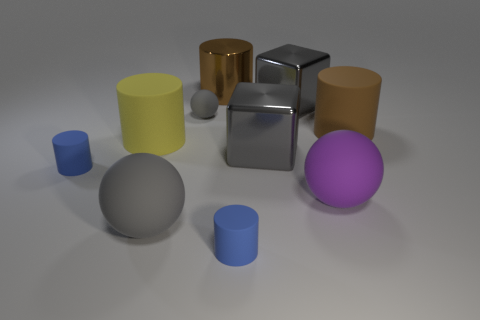What size is the yellow object that is the same shape as the brown metal object?
Keep it short and to the point. Large. How many spheres are the same color as the shiny cylinder?
Offer a very short reply. 0. There is another big ball that is made of the same material as the purple ball; what is its color?
Keep it short and to the point. Gray. Are there any purple cylinders of the same size as the yellow thing?
Give a very brief answer. No. Are there more big brown things that are in front of the big gray matte sphere than brown metallic objects that are behind the yellow thing?
Ensure brevity in your answer.  No. Do the large object that is on the right side of the large purple rubber thing and the tiny cylinder that is left of the big gray matte sphere have the same material?
Make the answer very short. Yes. There is a yellow object that is the same size as the brown matte cylinder; what is its shape?
Offer a terse response. Cylinder. Are there any gray metal objects of the same shape as the yellow rubber object?
Your answer should be very brief. No. Do the big shiny object that is in front of the small gray rubber ball and the tiny cylinder to the left of the yellow object have the same color?
Give a very brief answer. No. There is a purple ball; are there any objects behind it?
Your answer should be very brief. Yes. 